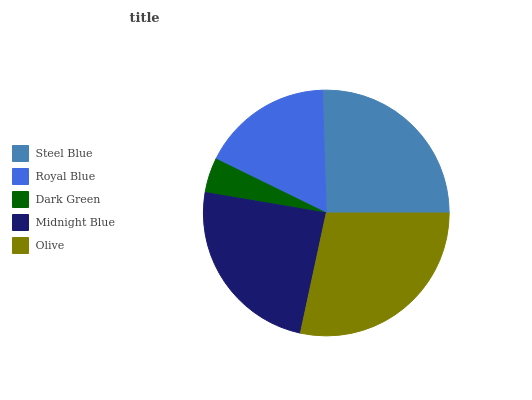Is Dark Green the minimum?
Answer yes or no. Yes. Is Olive the maximum?
Answer yes or no. Yes. Is Royal Blue the minimum?
Answer yes or no. No. Is Royal Blue the maximum?
Answer yes or no. No. Is Steel Blue greater than Royal Blue?
Answer yes or no. Yes. Is Royal Blue less than Steel Blue?
Answer yes or no. Yes. Is Royal Blue greater than Steel Blue?
Answer yes or no. No. Is Steel Blue less than Royal Blue?
Answer yes or no. No. Is Midnight Blue the high median?
Answer yes or no. Yes. Is Midnight Blue the low median?
Answer yes or no. Yes. Is Steel Blue the high median?
Answer yes or no. No. Is Olive the low median?
Answer yes or no. No. 